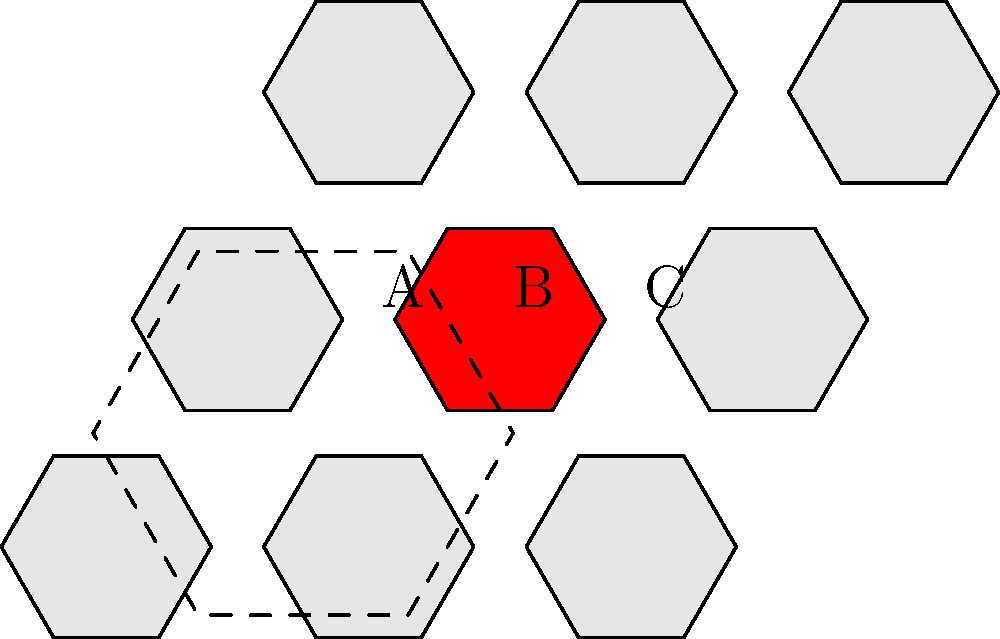As a custom game piece designer, you're creating a hexagonal game board. The board is made up of smaller hexagonal tiles that tessellate perfectly. If the side length of each small hexagon is 1 inch, what is the side length of the large hexagon (outlined in dashed lines) that encompasses a 3x3 grid of smaller hexagons? Let's approach this step-by-step:

1) In a regular hexagon, the distance between parallel sides is $\sqrt{3}$ times the side length.

2) The large hexagon encompasses 3 small hexagons across its width. So its width is 3 times the width of a small hexagon.

3) The width of the large hexagon = $3 \times \sqrt{3}$ inches

4) In a regular hexagon, the side length is equal to the radius of its circumscribed circle. This radius is equal to the distance from the center to any vertex.

5) Looking at the diagram, we can see that this radius of the large hexagon is composed of:
   - Half the width of the middle hexagon: $\frac{1}{2} \times \sqrt{3}$
   - The full width of one hexagon: $\sqrt{3}$

6) So, the side length of the large hexagon = $\frac{1}{2} \times \sqrt{3} + \sqrt{3} = \frac{3}{2} \times \sqrt{3}$ inches

7) Simplifying: $\frac{3}{2} \times \sqrt{3} = \frac{3\sqrt{3}}{2}$ inches
Answer: $\frac{3\sqrt{3}}{2}$ inches 